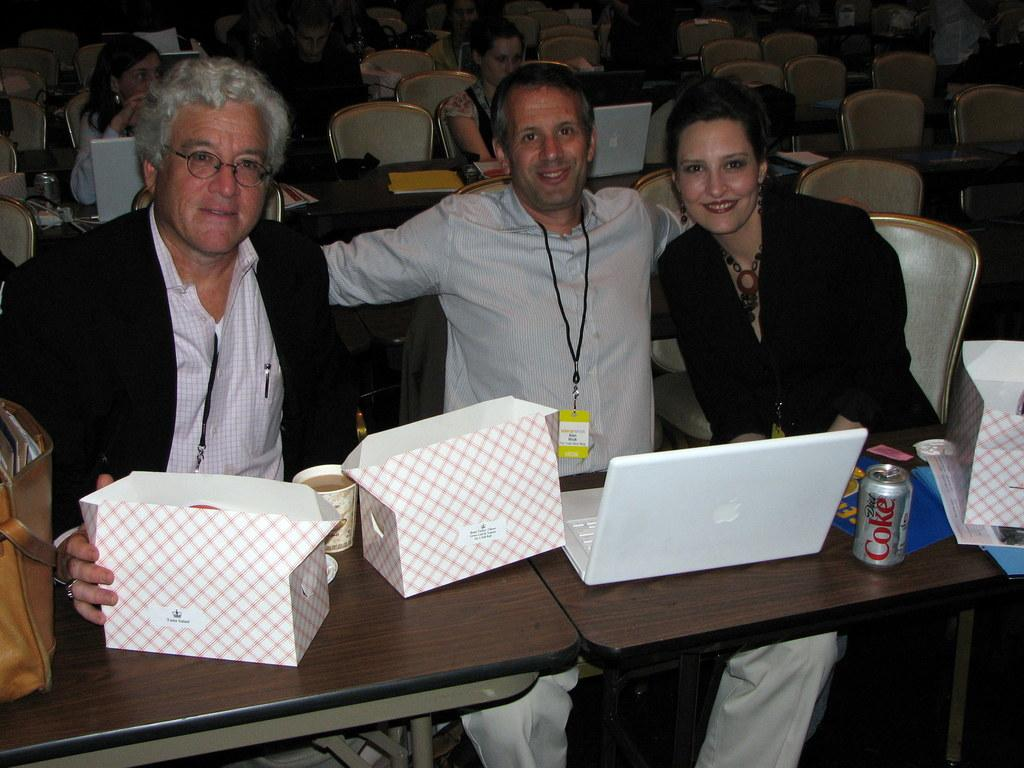How many people are in the image? There is a group of people in the image. What are the people doing in the image? The people are sitting on chairs. What can be seen on the table in the image? There is a laptop, a coke tin, a box, a cup with tea, and a bag on the table. What type of electronic device is on the table? There is a laptop on the table. How many chairs are in the image? There are chairs in the image. What type of collar is visible on the laptop in the image? There is no collar present on the laptop in the image. What type of steel is used to construct the chairs in the image? The chairs in the image are not described as being made of steel, so we cannot determine the type of steel used. 